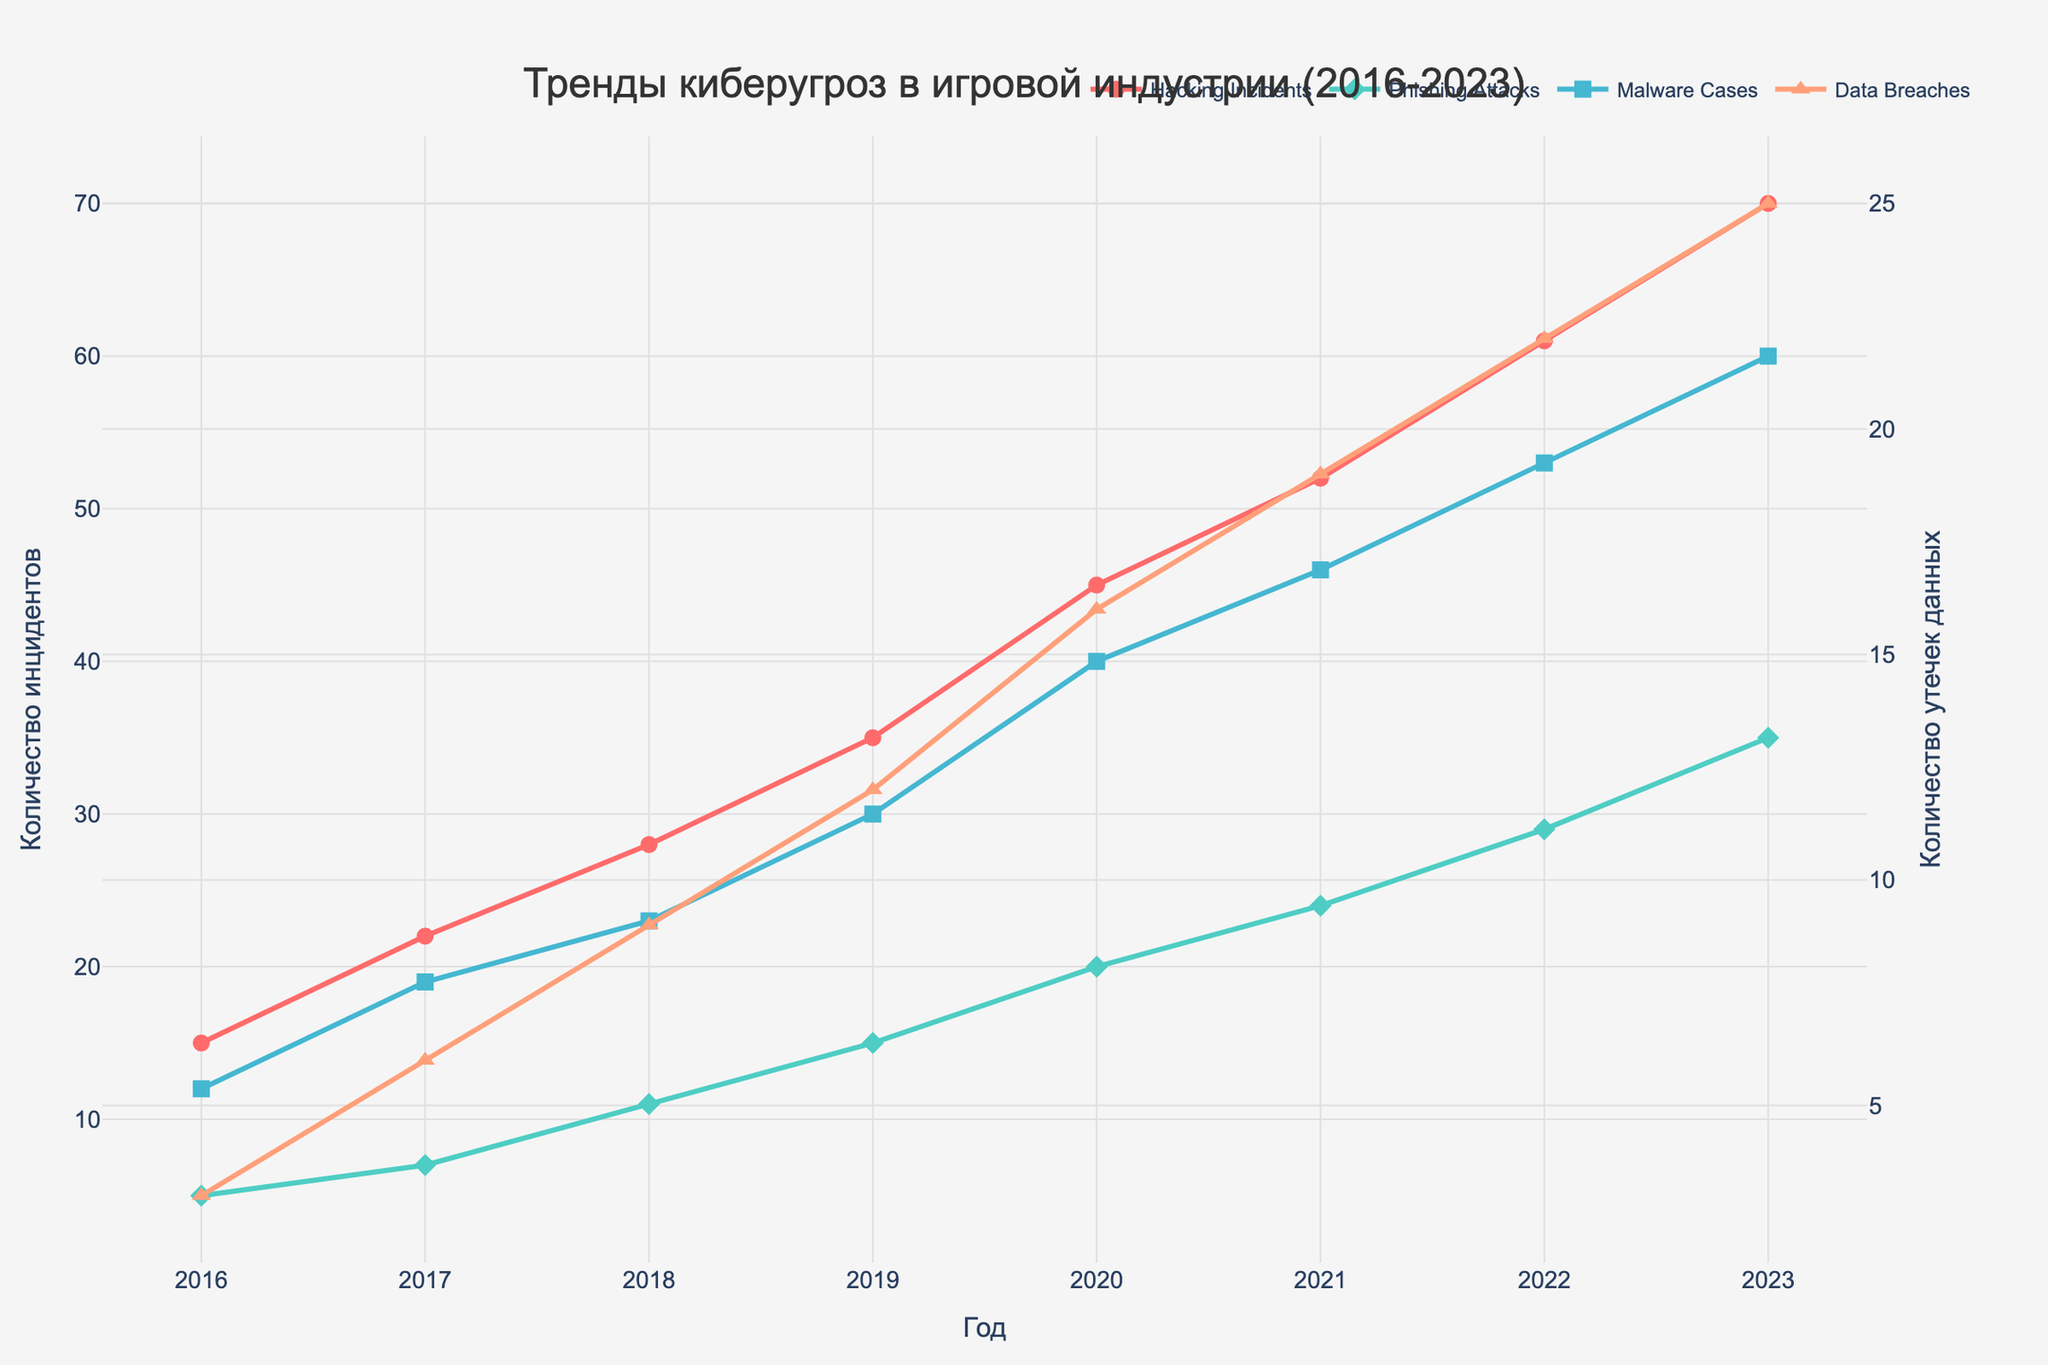What is the title of the figure? The title of the figure is prominently displayed at the top of the plot.
Answer: Тренды киберугроз в игровой индустрии (2016-2023) Which type of cyber threat had the highest number of incidents in 2021? Looking at the data points for 2021, "Hacking Incidents" has the highest value among the cyber threats listed.
Answer: Hacking Incidents How many Phishing Attacks were there in 2020? Check the data point for "Phishing Attacks" in the year 2020.
Answer: 20 What is the overall trend observed in the Malware Cases from 2016 to 2023? Observing the graph for "Malware Cases" from the start year to the end year, the number is consistently increasing each year.
Answer: Consistently increasing Compare the number of Data Breaches in 2016 and 2023. Look at the values for "Data Breaches" in both 2016 and 2023, the number has increased from 3 in 2016 to 25 in 2023.
Answer: Increased What is the average number of Hacking Incidents over the 8 years? Sum the number of Hacking Incidents for all years and divide by the number of years (15+22+28+35+45+52+61+70) / 8.
Answer: 41 Between which years did the Phishing Attacks see the biggest increase? Calculate and compare the year-over-year differences for Phishing Attacks; the biggest increase is between 2022 and 2023, from 29 to 35.
Answer: 2022 and 2023 What is the trend for Data Breaches compared to Hacking Incidents over the past eight years? Both Data Breaches and Hacking Incidents show an increasing trend, but Hacking Incidents increased at a higher rate compared to Data Breaches.
Answer: Both increased, Hacking Incidents more Which year had the highest combined total of all cyber threats? Sum all incidents for each year and compare (Hacking Incidents + Phishing Attacks + Malware Cases + Data Breaches) for each year; 2023 has the highest combined total (70+35+60+25).
Answer: 2023 